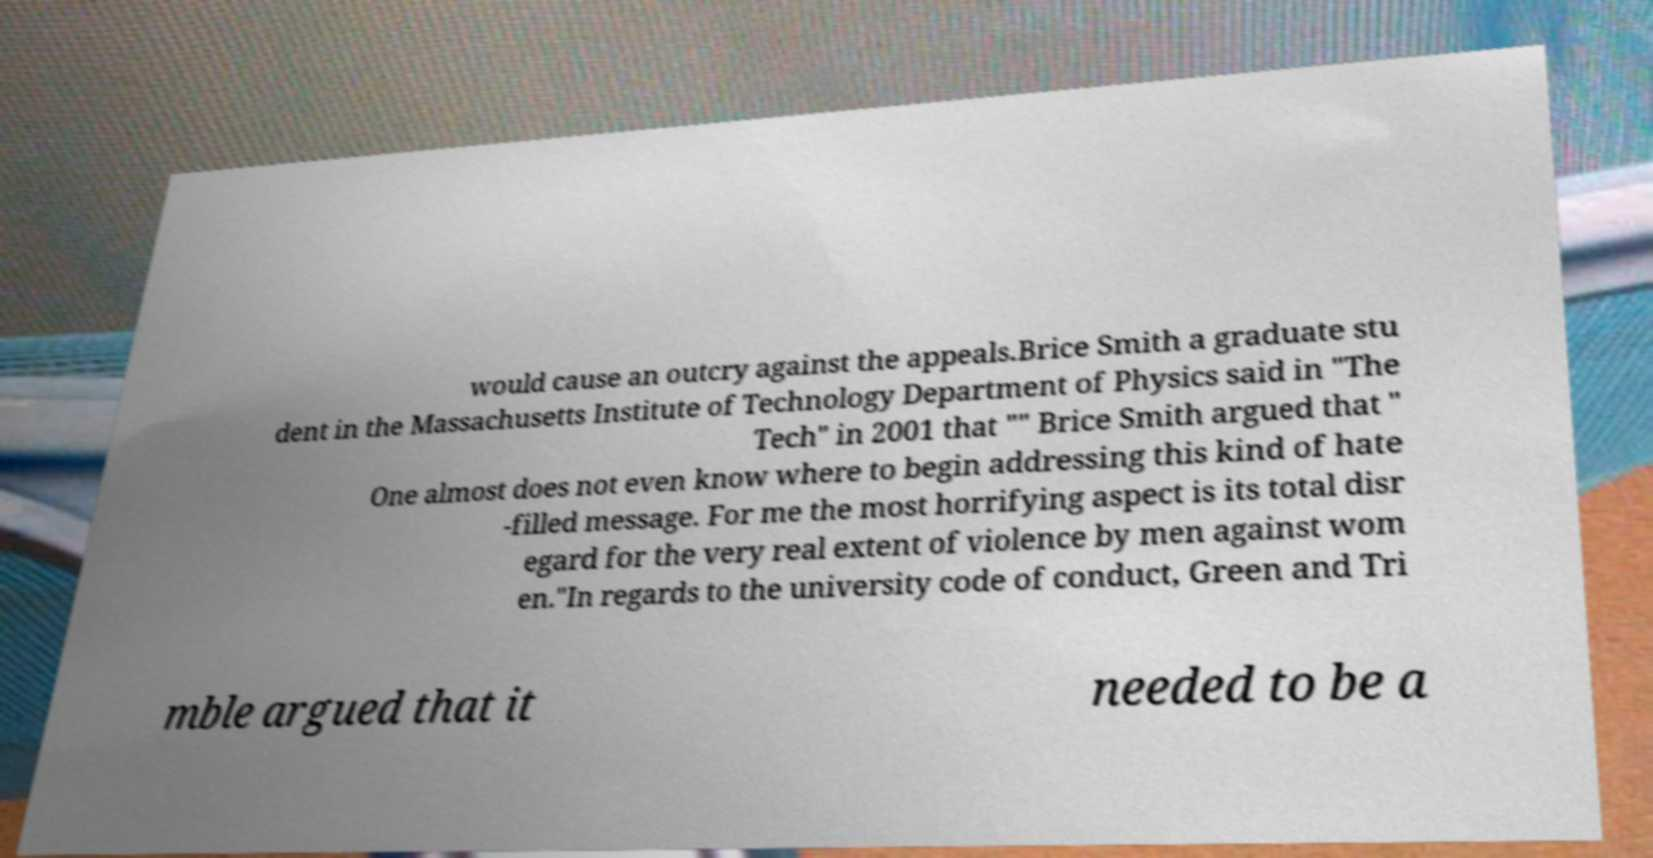Can you accurately transcribe the text from the provided image for me? would cause an outcry against the appeals.Brice Smith a graduate stu dent in the Massachusetts Institute of Technology Department of Physics said in "The Tech" in 2001 that "" Brice Smith argued that " One almost does not even know where to begin addressing this kind of hate -filled message. For me the most horrifying aspect is its total disr egard for the very real extent of violence by men against wom en."In regards to the university code of conduct, Green and Tri mble argued that it needed to be a 